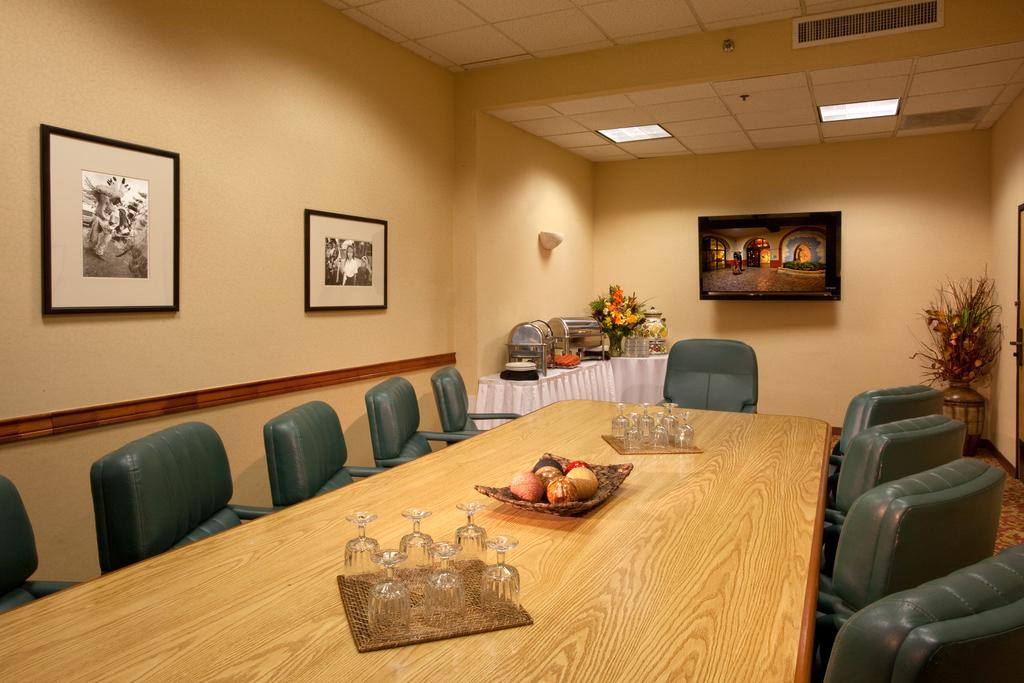What type of furniture is present in the image? There is a table and chairs in the image. What objects can be seen on the table? There are glasses on the table. What decorative items are attached to the wall? Paintings are attached to the wall. What type of container is present in the image? There is a flower vase in the image. How does the table expand in the image? The table does not expand in the image; it is stationary. 